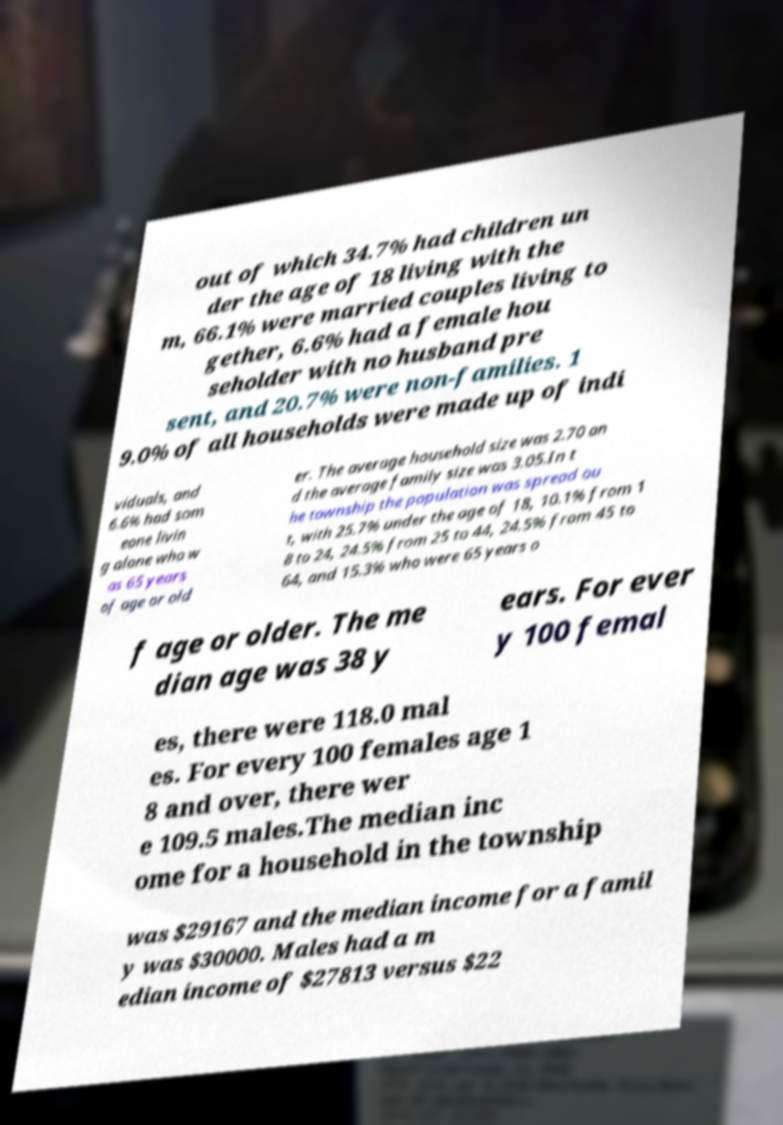I need the written content from this picture converted into text. Can you do that? out of which 34.7% had children un der the age of 18 living with the m, 66.1% were married couples living to gether, 6.6% had a female hou seholder with no husband pre sent, and 20.7% were non-families. 1 9.0% of all households were made up of indi viduals, and 6.6% had som eone livin g alone who w as 65 years of age or old er. The average household size was 2.70 an d the average family size was 3.05.In t he township the population was spread ou t, with 25.7% under the age of 18, 10.1% from 1 8 to 24, 24.5% from 25 to 44, 24.5% from 45 to 64, and 15.3% who were 65 years o f age or older. The me dian age was 38 y ears. For ever y 100 femal es, there were 118.0 mal es. For every 100 females age 1 8 and over, there wer e 109.5 males.The median inc ome for a household in the township was $29167 and the median income for a famil y was $30000. Males had a m edian income of $27813 versus $22 